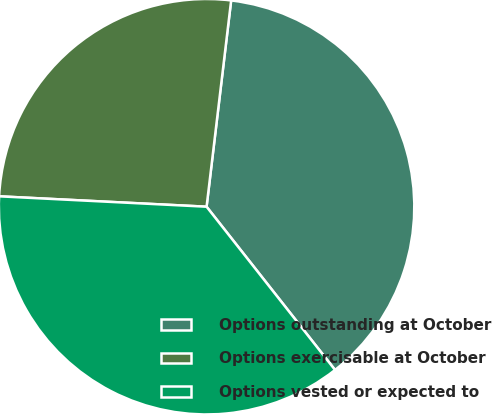Convert chart to OTSL. <chart><loc_0><loc_0><loc_500><loc_500><pie_chart><fcel>Options outstanding at October<fcel>Options exercisable at October<fcel>Options vested or expected to<nl><fcel>37.5%<fcel>26.09%<fcel>36.41%<nl></chart> 